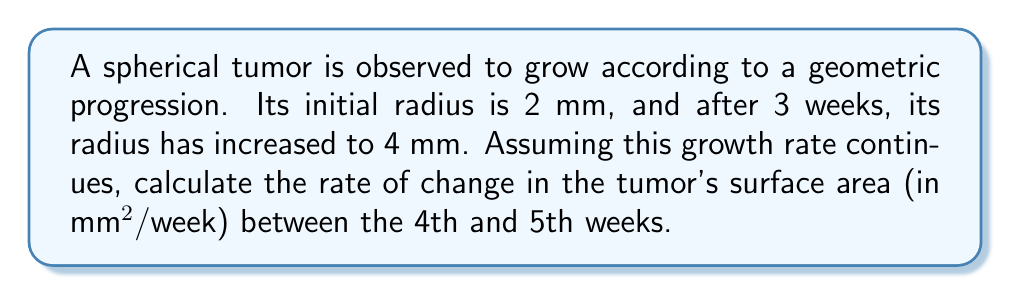Can you answer this question? 1) First, let's find the common ratio (r) of the geometric progression:
   $r = \sqrt[3]{\frac{4}{2}} = \sqrt[3]{2} \approx 1.2599$

2) Now we can calculate the radius at week 4 and week 5:
   Week 4: $2 * r^4 = 2 * (1.2599)^4 \approx 5.0397$ mm
   Week 5: $2 * r^5 = 2 * (1.2599)^5 \approx 6.3496$ mm

3) The surface area of a sphere is given by the formula $A = 4\pi r^2$. Let's calculate the surface areas:
   Week 4: $A_4 = 4\pi (5.0397)^2 \approx 318.3949$ mm²
   Week 5: $A_5 = 4\pi (6.3496)^2 \approx 506.7073$ mm²

4) The rate of change in surface area is the difference between these areas divided by the time interval (1 week):
   Rate of change = $\frac{A_5 - A_4}{1} = 506.7073 - 318.3949 = 188.3124$ mm²/week
Answer: 188.31 mm²/week 